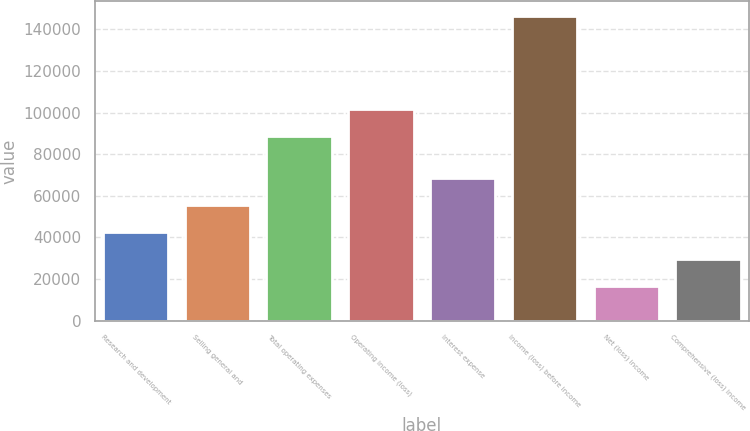<chart> <loc_0><loc_0><loc_500><loc_500><bar_chart><fcel>Research and development<fcel>Selling general and<fcel>Total operating expenses<fcel>Operating income (loss)<fcel>Interest expense<fcel>Income (loss) before income<fcel>Net (loss) income<fcel>Comprehensive (loss) income<nl><fcel>42484<fcel>55447<fcel>88844<fcel>101807<fcel>68410<fcel>146188<fcel>16558<fcel>29521<nl></chart> 